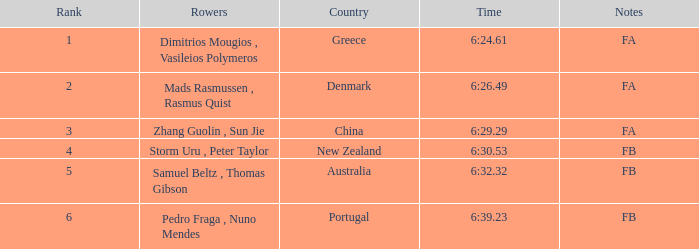What country has a rank smaller than 6, a time of 6:32.32 and notes of FB? Australia. 